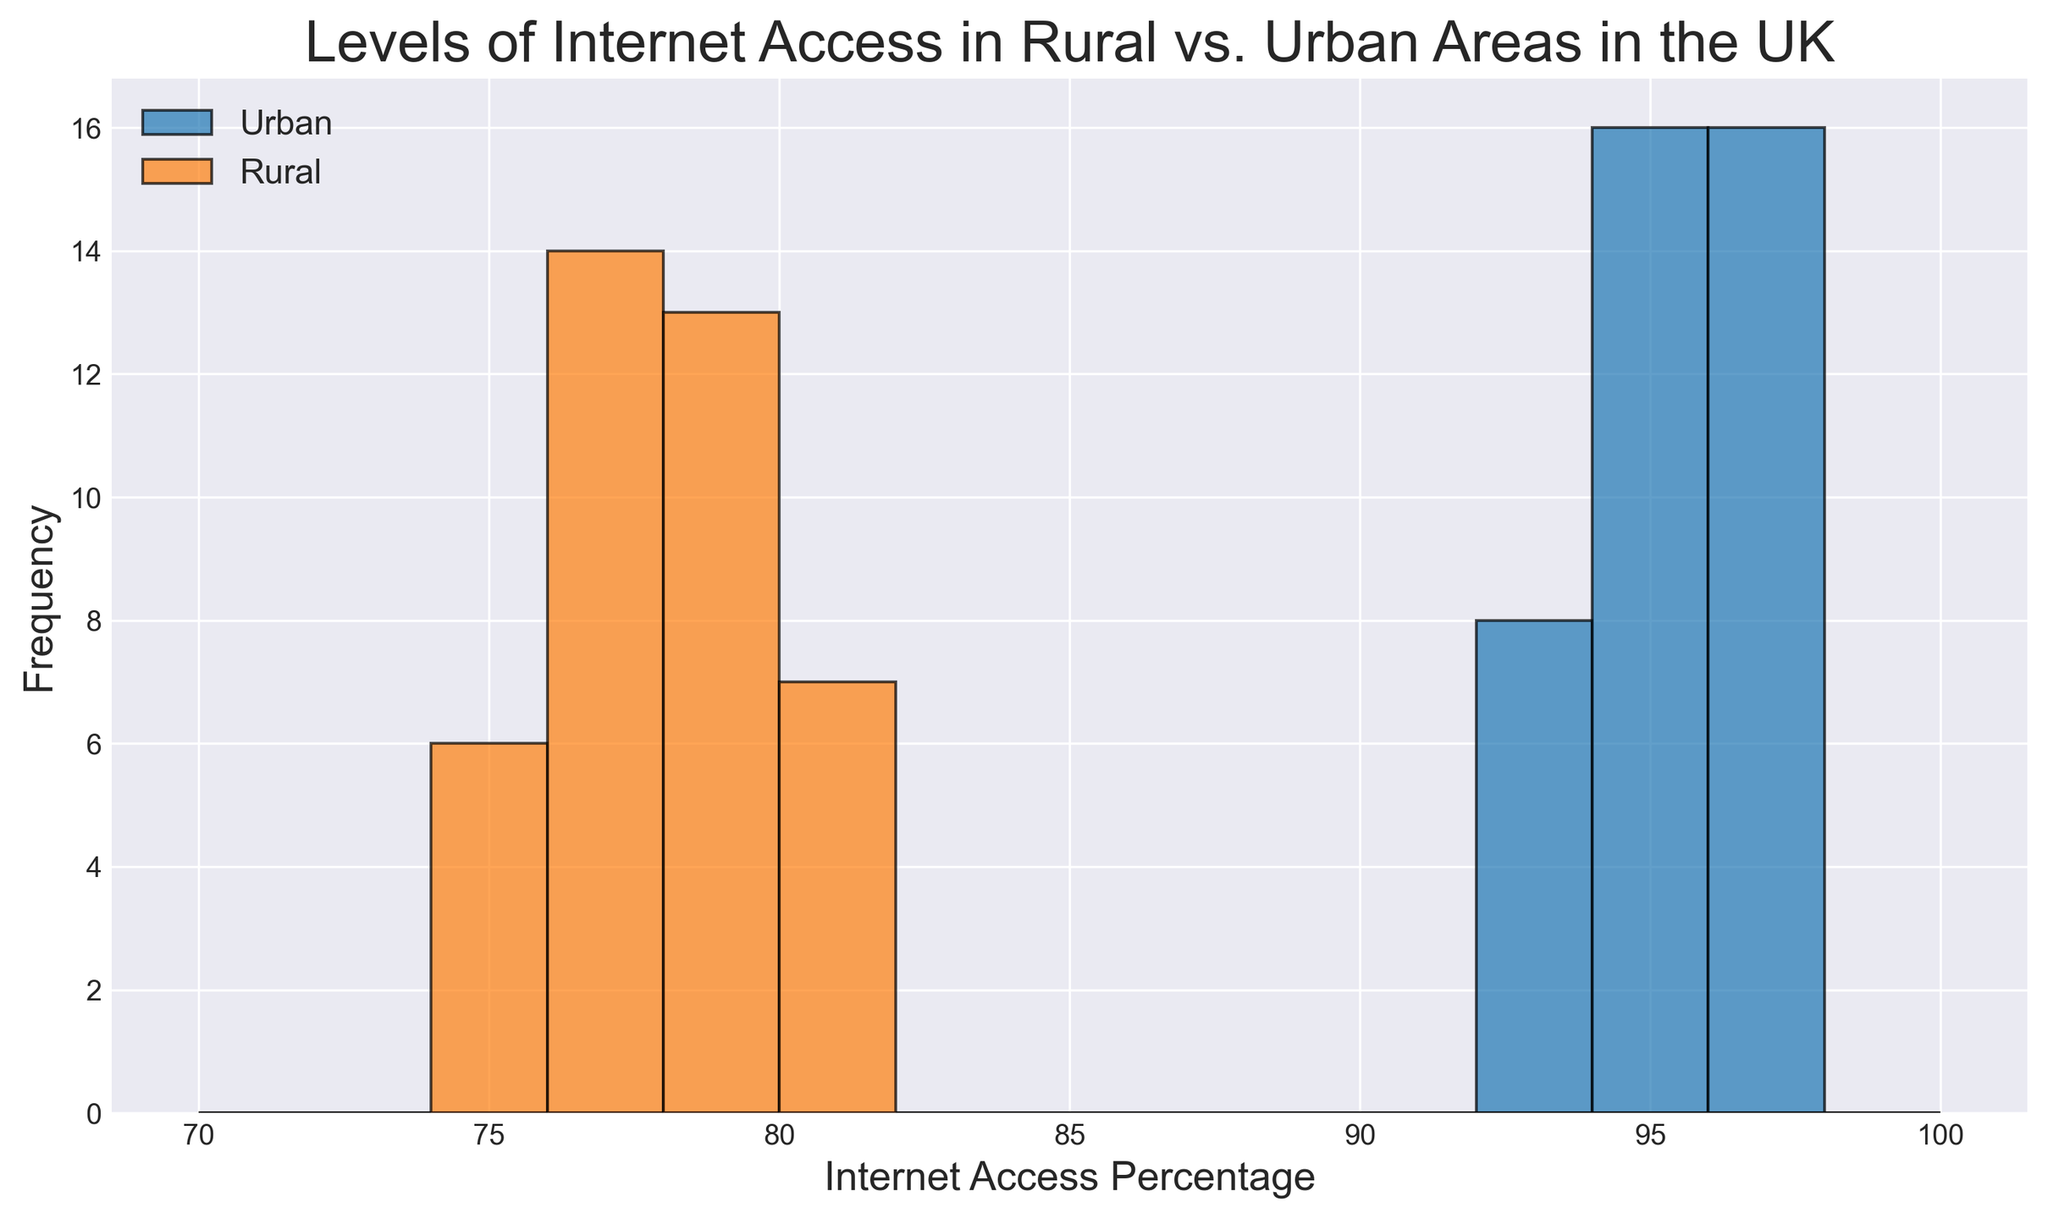Which region has a higher overall level of internet access? From the histogram, we can see that the bars representing the urban areas are centered around higher internet access percentages (93-97%) compared to rural areas (75-80%). This indicates that urban areas have a higher overall level of internet access.
Answer: Urban What is the most common internet access percentage range in urban areas? The most frequent bar (i.e., highest bar) for urban areas in the histogram is around the 94-96% range. This range has the highest frequency, indicating it is the most common internet access percentage.
Answer: 94-96% Which region appears to have more variability in internet access levels? In the histogram, the bars for rural areas are spread out over a wider range (75-80%) compared to urban areas (93-97%). This indicates that rural areas have more variability in internet access levels.
Answer: Rural Are there any overlapping ranges of internet access percentages between rural and urban areas? Examining the histogram, we can see that the ranges for urban areas (93-97%) and rural areas (75-80%) do not overlap, indicating no common internet access percentage range between the two regions.
Answer: No What is the height of the tallest bar for rural areas? The tallest bar for rural areas in the histogram is around the internet access percentage of 78%, and we see that the height is approximately the same as the other major peaks, showing 6 verifications. This indicates that this is one of the most frequent values.
Answer: 6 Which region has bars extending to higher internet access percentages? The histogram demonstrates that urban areas have bars extending to higher internet access percentages (up to 97%), while rural areas do not have bars extending above 80%.
Answer: Urban Comparing the tallest bars from each region, which one has a higher frequency, and for which access range? The tallest bar for urban areas at 94-96% has a greater frequency compared to the tallest bar for rural areas at 78%, indicating that 94-96% internet access is more frequent in urban areas.
Answer: Urban, 94-96% What is the combined frequency of the two commonest internet access percentage ranges in rural areas? Two commonest access ranges in rural areas are around 75 and 78 percent, with each range having a frequency of approximately 6. Adding these together gives a combined frequency of 12.
Answer: 12 